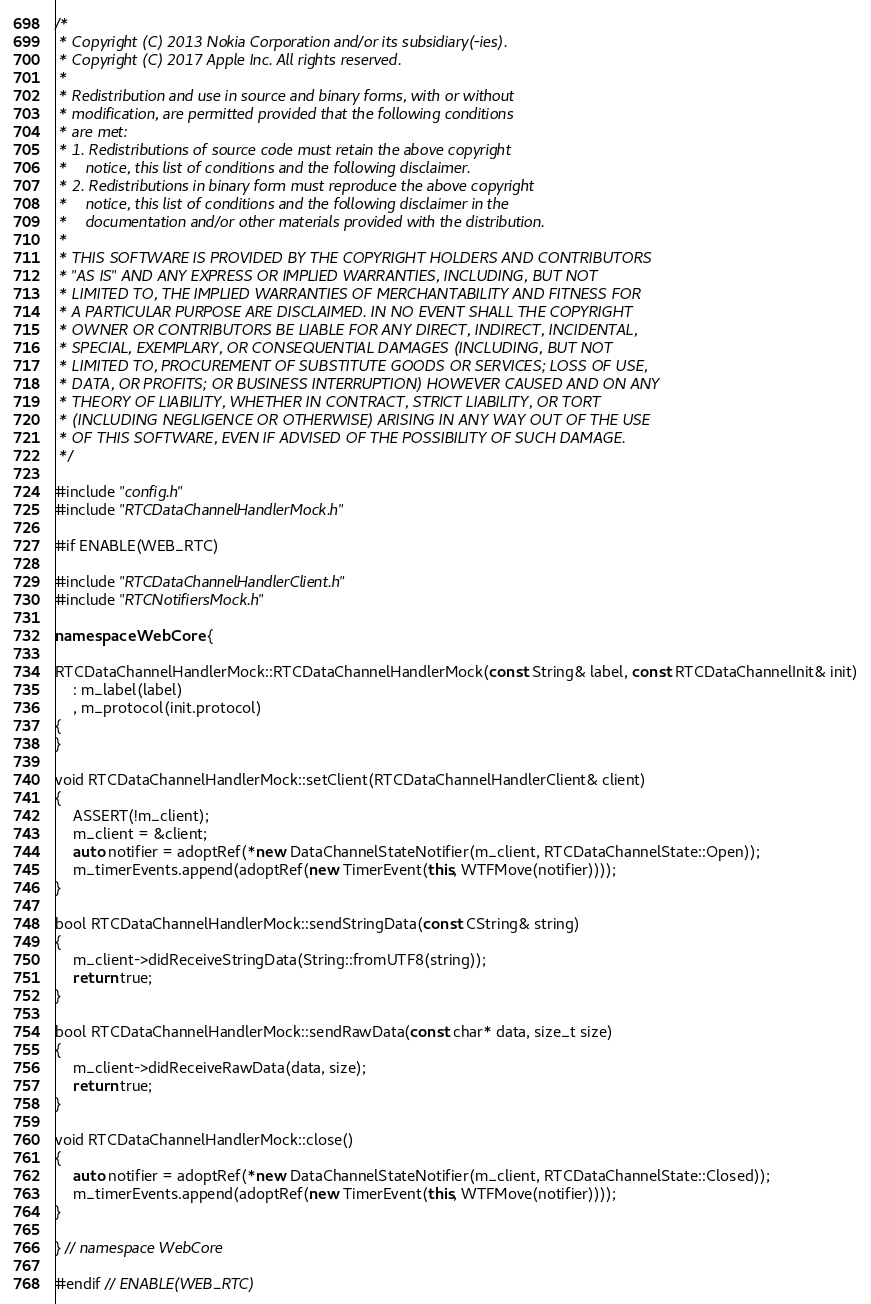<code> <loc_0><loc_0><loc_500><loc_500><_C++_>/*
 * Copyright (C) 2013 Nokia Corporation and/or its subsidiary(-ies).
 * Copyright (C) 2017 Apple Inc. All rights reserved.
 *
 * Redistribution and use in source and binary forms, with or without
 * modification, are permitted provided that the following conditions
 * are met:
 * 1. Redistributions of source code must retain the above copyright
 *    notice, this list of conditions and the following disclaimer.
 * 2. Redistributions in binary form must reproduce the above copyright
 *    notice, this list of conditions and the following disclaimer in the
 *    documentation and/or other materials provided with the distribution.
 *
 * THIS SOFTWARE IS PROVIDED BY THE COPYRIGHT HOLDERS AND CONTRIBUTORS
 * "AS IS" AND ANY EXPRESS OR IMPLIED WARRANTIES, INCLUDING, BUT NOT
 * LIMITED TO, THE IMPLIED WARRANTIES OF MERCHANTABILITY AND FITNESS FOR
 * A PARTICULAR PURPOSE ARE DISCLAIMED. IN NO EVENT SHALL THE COPYRIGHT
 * OWNER OR CONTRIBUTORS BE LIABLE FOR ANY DIRECT, INDIRECT, INCIDENTAL,
 * SPECIAL, EXEMPLARY, OR CONSEQUENTIAL DAMAGES (INCLUDING, BUT NOT
 * LIMITED TO, PROCUREMENT OF SUBSTITUTE GOODS OR SERVICES; LOSS OF USE,
 * DATA, OR PROFITS; OR BUSINESS INTERRUPTION) HOWEVER CAUSED AND ON ANY
 * THEORY OF LIABILITY, WHETHER IN CONTRACT, STRICT LIABILITY, OR TORT
 * (INCLUDING NEGLIGENCE OR OTHERWISE) ARISING IN ANY WAY OUT OF THE USE
 * OF THIS SOFTWARE, EVEN IF ADVISED OF THE POSSIBILITY OF SUCH DAMAGE.
 */

#include "config.h"
#include "RTCDataChannelHandlerMock.h"

#if ENABLE(WEB_RTC)

#include "RTCDataChannelHandlerClient.h"
#include "RTCNotifiersMock.h"

namespace WebCore {

RTCDataChannelHandlerMock::RTCDataChannelHandlerMock(const String& label, const RTCDataChannelInit& init)
    : m_label(label)
    , m_protocol(init.protocol)
{
}

void RTCDataChannelHandlerMock::setClient(RTCDataChannelHandlerClient& client)
{
    ASSERT(!m_client);
    m_client = &client;
    auto notifier = adoptRef(*new DataChannelStateNotifier(m_client, RTCDataChannelState::Open));
    m_timerEvents.append(adoptRef(new TimerEvent(this, WTFMove(notifier))));
}

bool RTCDataChannelHandlerMock::sendStringData(const CString& string)
{
    m_client->didReceiveStringData(String::fromUTF8(string));
    return true;
}

bool RTCDataChannelHandlerMock::sendRawData(const char* data, size_t size)
{
    m_client->didReceiveRawData(data, size);
    return true;
}

void RTCDataChannelHandlerMock::close()
{
    auto notifier = adoptRef(*new DataChannelStateNotifier(m_client, RTCDataChannelState::Closed));
    m_timerEvents.append(adoptRef(new TimerEvent(this, WTFMove(notifier))));
}

} // namespace WebCore

#endif // ENABLE(WEB_RTC)
</code> 